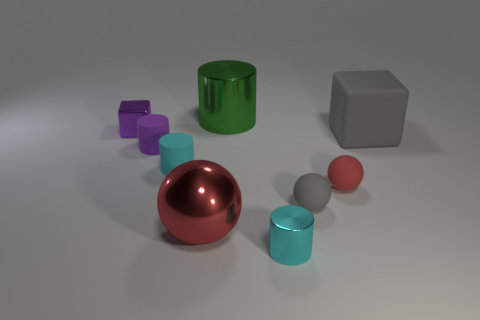Is the large red thing made of the same material as the small cyan cylinder in front of the gray matte sphere?
Provide a short and direct response. Yes. How many other objects are the same size as the rubber cube?
Offer a very short reply. 2. There is a gray matte object that is on the left side of the red sphere that is to the right of the large red ball; is there a large green shiny object that is in front of it?
Offer a very short reply. No. The red rubber thing is what size?
Offer a very short reply. Small. There is a purple thing in front of the small purple cube; what size is it?
Offer a very short reply. Small. There is a rubber object behind the purple matte object; is its size the same as the red matte ball?
Give a very brief answer. No. Are there any other things that have the same color as the large cube?
Give a very brief answer. Yes. What is the shape of the large green object?
Your answer should be compact. Cylinder. How many cylinders are both in front of the small gray thing and on the left side of the large sphere?
Your answer should be very brief. 0. Is the color of the small metal block the same as the metal sphere?
Your answer should be very brief. No. 